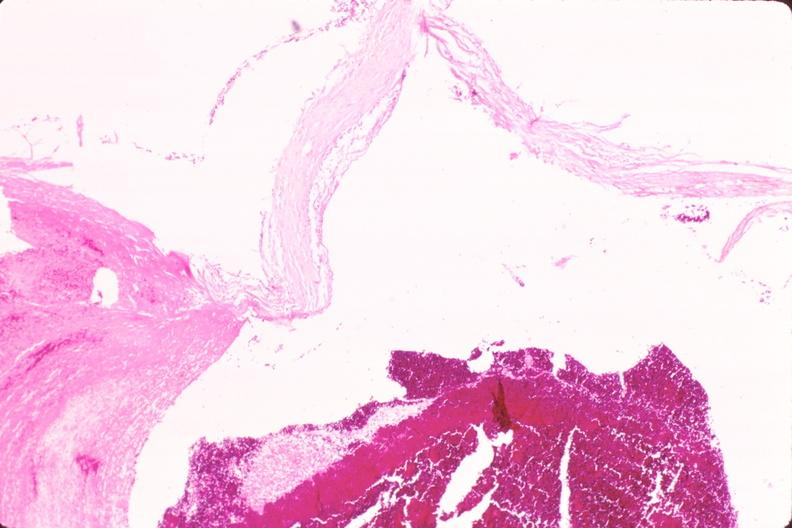s infant body present?
Answer the question using a single word or phrase. No 